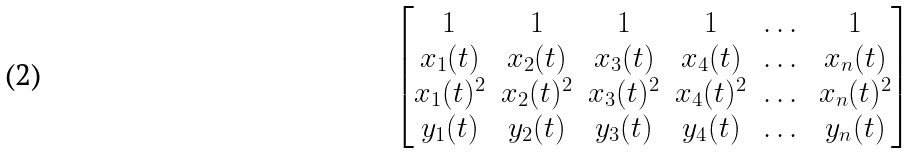<formula> <loc_0><loc_0><loc_500><loc_500>\begin{bmatrix} 1 & 1 & 1 & 1 & \dots & 1 \\ x _ { 1 } ( t ) & x _ { 2 } ( t ) & x _ { 3 } ( t ) & x _ { 4 } ( t ) & \dots & x _ { n } ( t ) \\ x _ { 1 } ( t ) ^ { 2 } & x _ { 2 } ( t ) ^ { 2 } & x _ { 3 } ( t ) ^ { 2 } & x _ { 4 } ( t ) ^ { 2 } & \dots & x _ { n } ( t ) ^ { 2 } \\ y _ { 1 } ( t ) & y _ { 2 } ( t ) & y _ { 3 } ( t ) & y _ { 4 } ( t ) & \dots & y _ { n } ( t ) \end{bmatrix}</formula> 